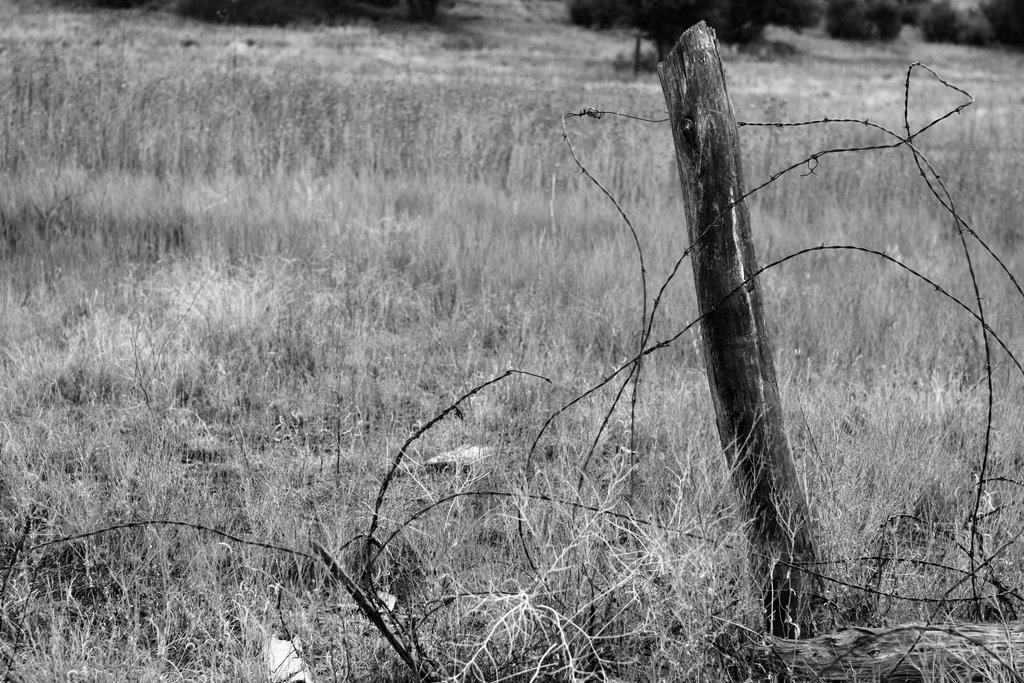Please provide a concise description of this image. This is a black and white image. I think this is the dried grass. I can see the wooden stick. I think this is a fence wire. 